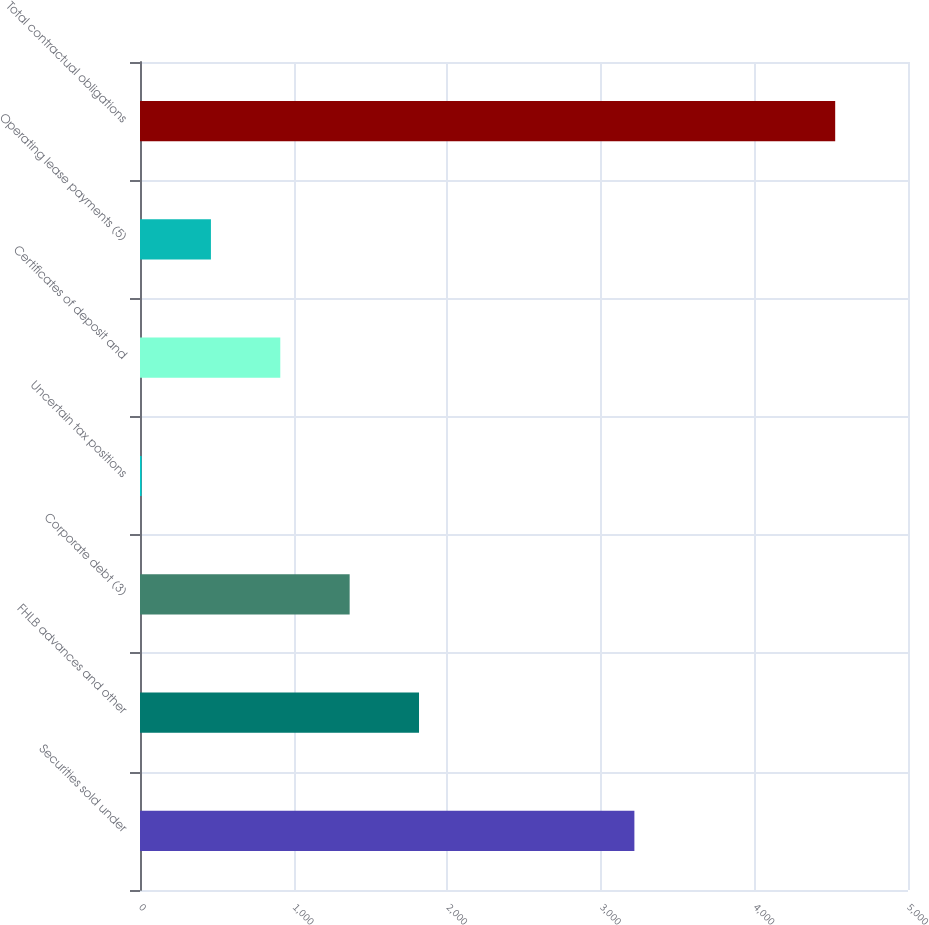<chart> <loc_0><loc_0><loc_500><loc_500><bar_chart><fcel>Securities sold under<fcel>FHLB advances and other<fcel>Corporate debt (3)<fcel>Uncertain tax positions<fcel>Certificates of deposit and<fcel>Operating lease payments (5)<fcel>Total contractual obligations<nl><fcel>3218.7<fcel>1816.52<fcel>1364.94<fcel>10.2<fcel>913.36<fcel>461.78<fcel>4526<nl></chart> 